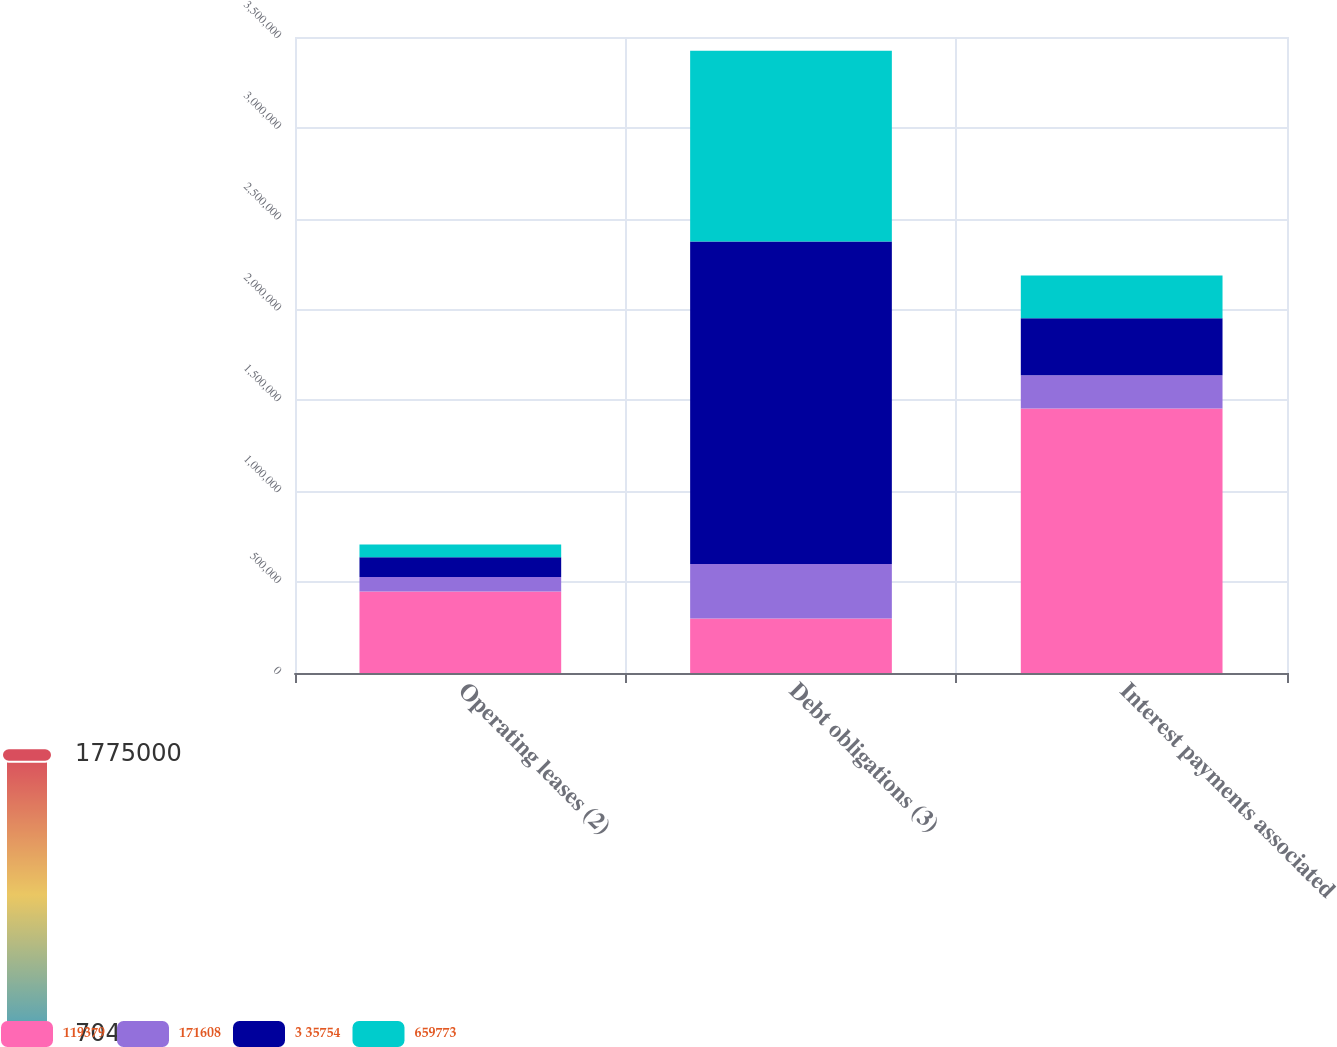Convert chart. <chart><loc_0><loc_0><loc_500><loc_500><stacked_bar_chart><ecel><fcel>Operating leases (2)<fcel>Debt obligations (3)<fcel>Interest payments associated<nl><fcel>119379<fcel>448721<fcel>300000<fcel>1.45606e+06<nl><fcel>171608<fcel>79789<fcel>300000<fcel>182268<nl><fcel>3 35754<fcel>108331<fcel>1.775e+06<fcel>314539<nl><fcel>659773<fcel>70430<fcel>1.05e+06<fcel>234356<nl></chart> 